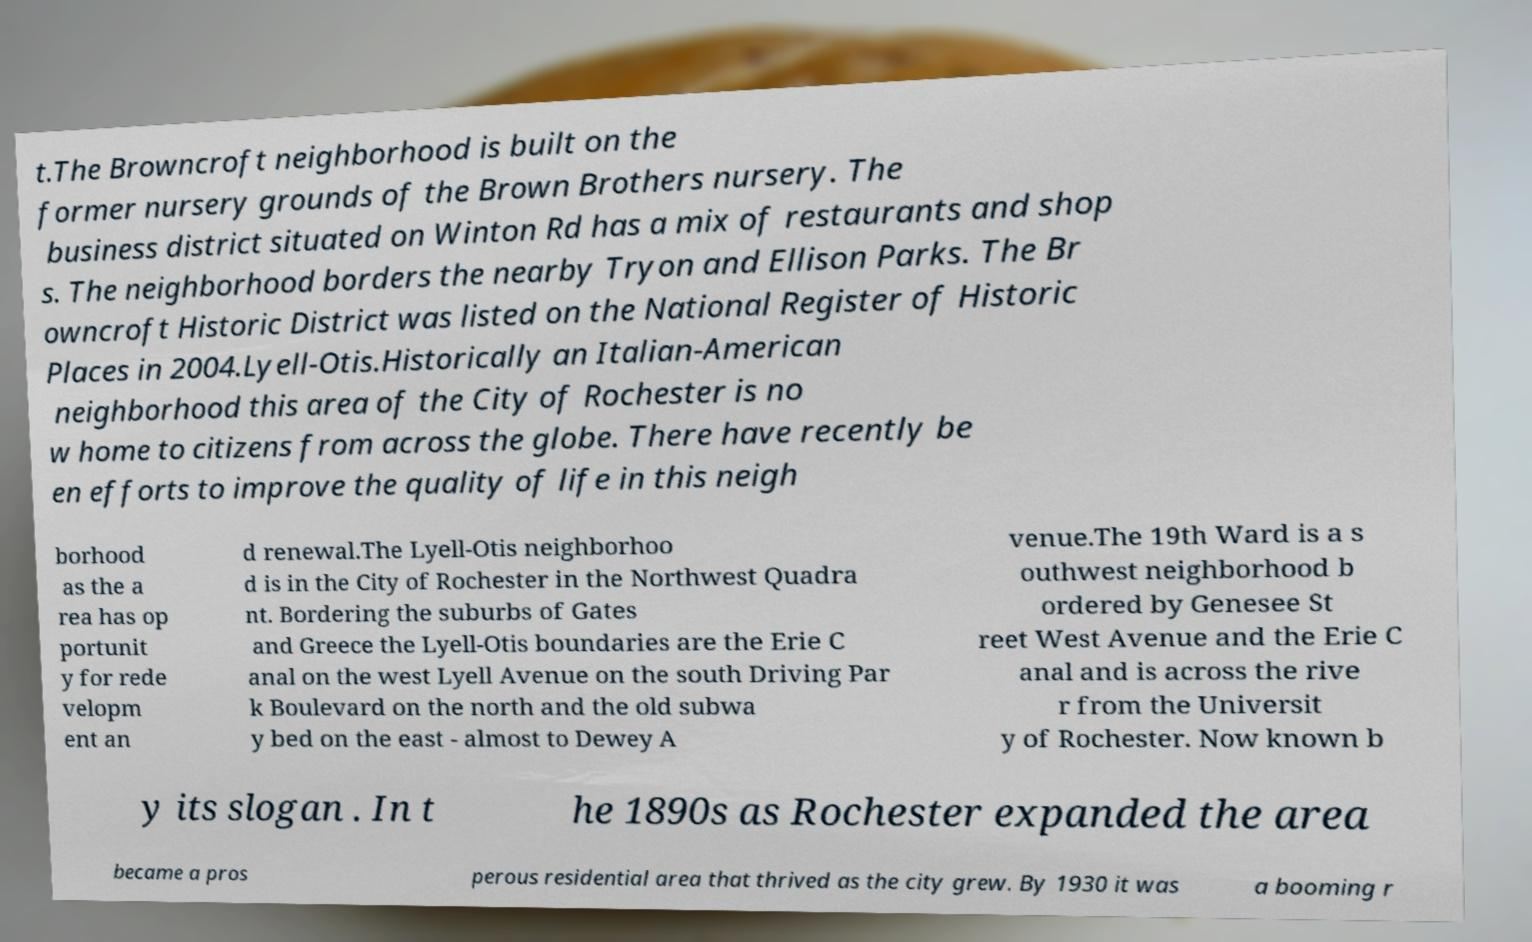Please identify and transcribe the text found in this image. t.The Browncroft neighborhood is built on the former nursery grounds of the Brown Brothers nursery. The business district situated on Winton Rd has a mix of restaurants and shop s. The neighborhood borders the nearby Tryon and Ellison Parks. The Br owncroft Historic District was listed on the National Register of Historic Places in 2004.Lyell-Otis.Historically an Italian-American neighborhood this area of the City of Rochester is no w home to citizens from across the globe. There have recently be en efforts to improve the quality of life in this neigh borhood as the a rea has op portunit y for rede velopm ent an d renewal.The Lyell-Otis neighborhoo d is in the City of Rochester in the Northwest Quadra nt. Bordering the suburbs of Gates and Greece the Lyell-Otis boundaries are the Erie C anal on the west Lyell Avenue on the south Driving Par k Boulevard on the north and the old subwa y bed on the east - almost to Dewey A venue.The 19th Ward is a s outhwest neighborhood b ordered by Genesee St reet West Avenue and the Erie C anal and is across the rive r from the Universit y of Rochester. Now known b y its slogan . In t he 1890s as Rochester expanded the area became a pros perous residential area that thrived as the city grew. By 1930 it was a booming r 